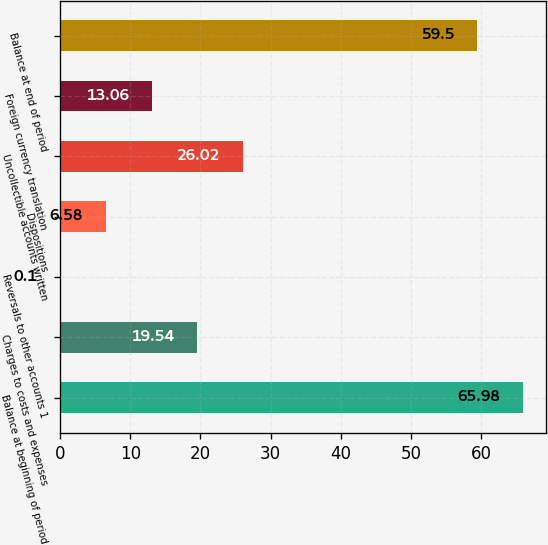Convert chart to OTSL. <chart><loc_0><loc_0><loc_500><loc_500><bar_chart><fcel>Balance at beginning of period<fcel>Charges to costs and expenses<fcel>Reversals to other accounts 1<fcel>Dispositions<fcel>Uncollectible accounts written<fcel>Foreign currency translation<fcel>Balance at end of period<nl><fcel>65.98<fcel>19.54<fcel>0.1<fcel>6.58<fcel>26.02<fcel>13.06<fcel>59.5<nl></chart> 